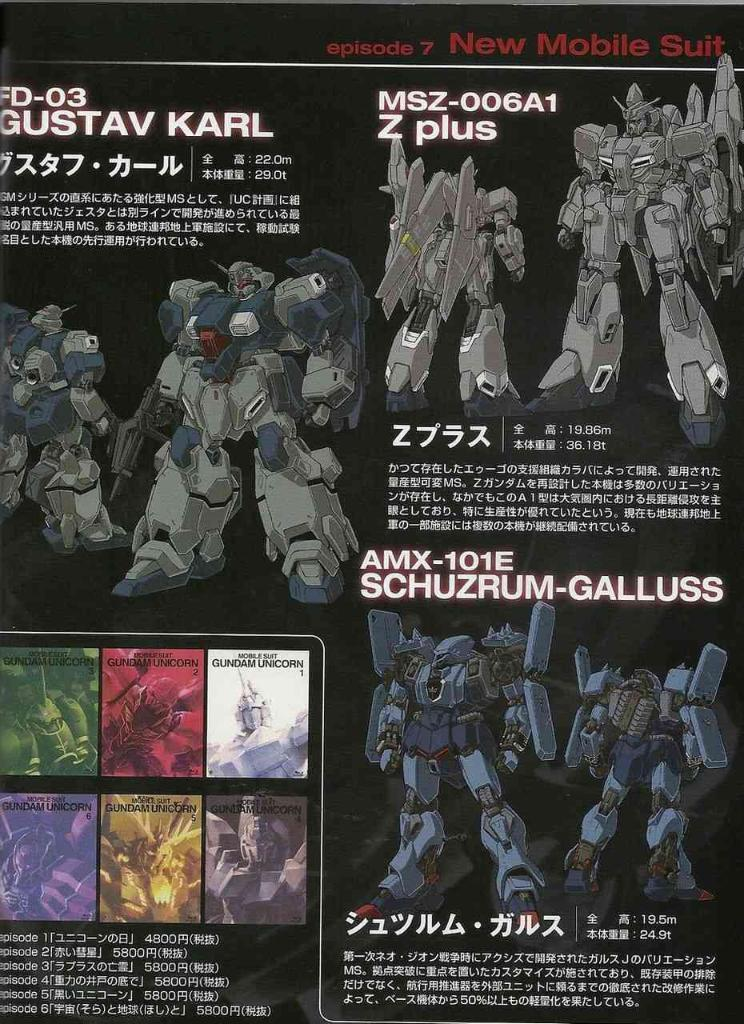<image>
Present a compact description of the photo's key features. A poster describes episode 7 an the New Mobile Suit. 